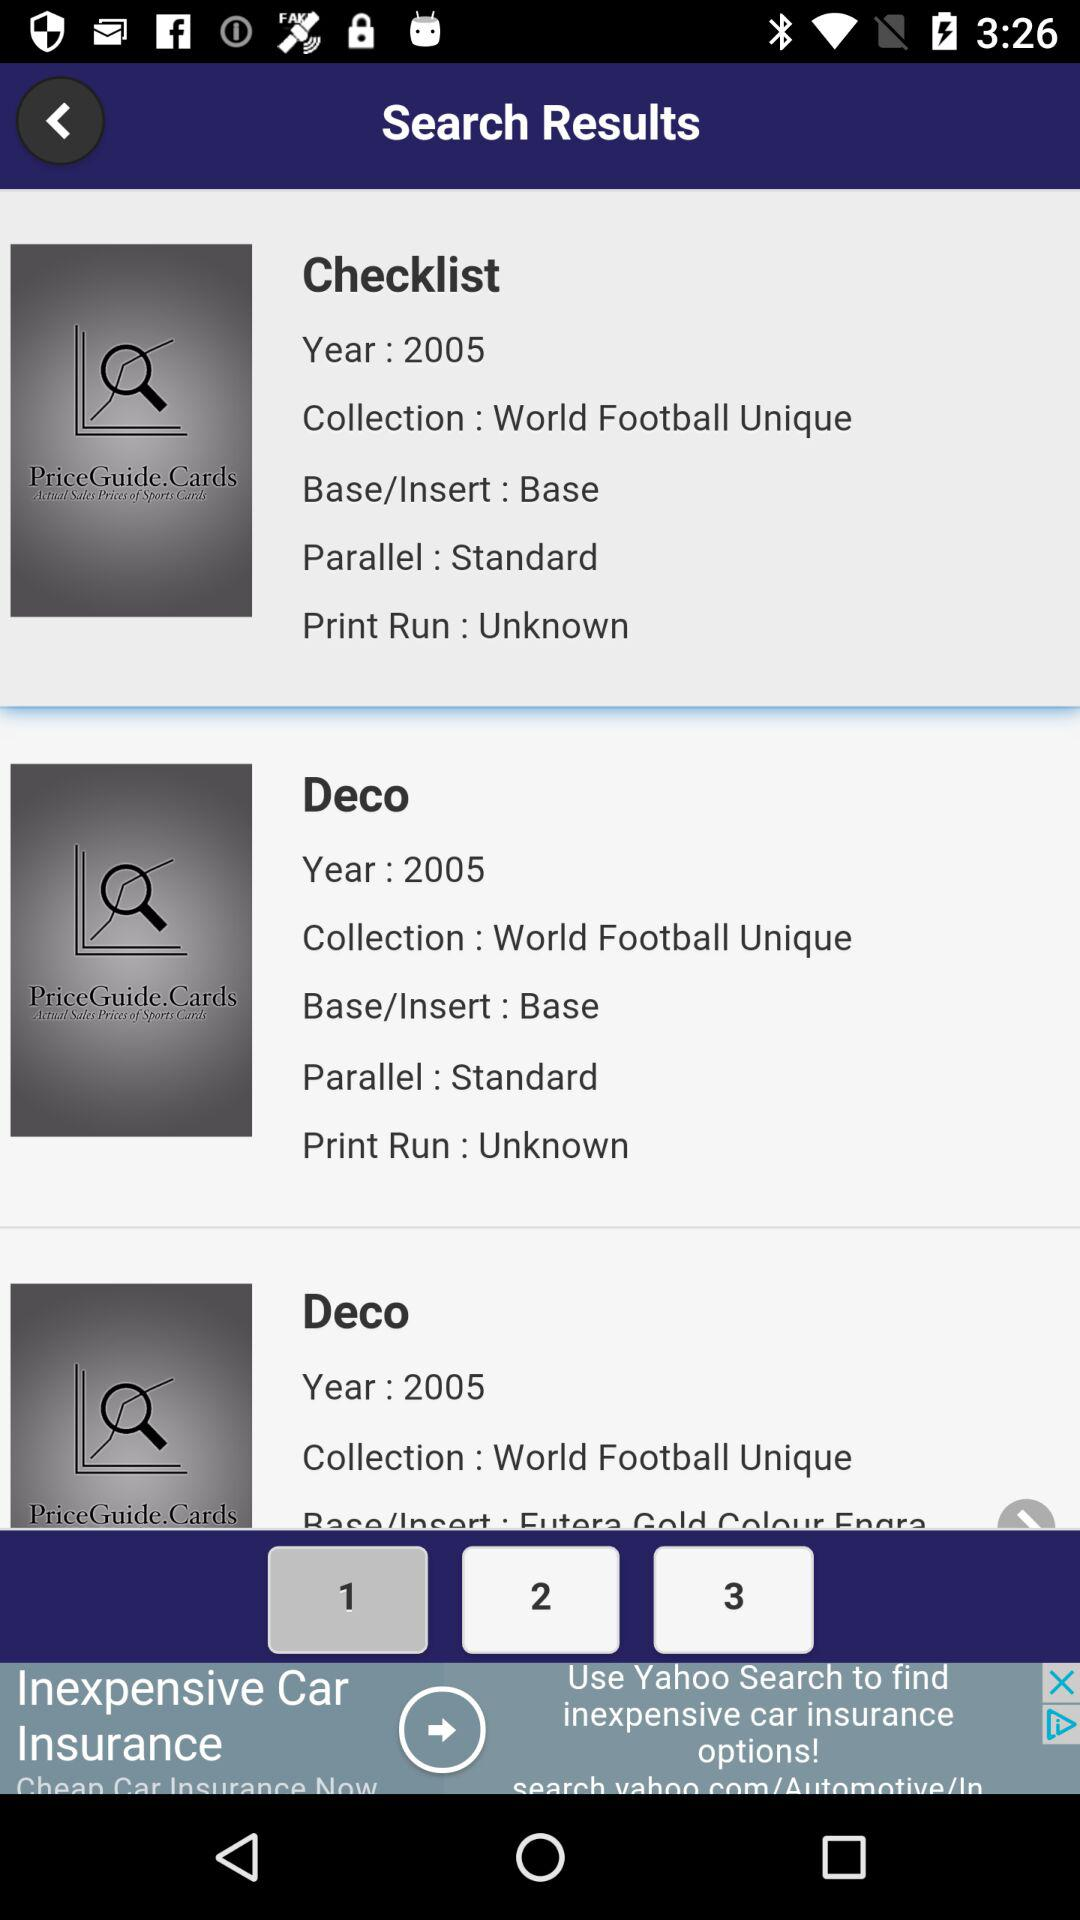What is the year of the checklist? The year of the checklist is 2005. 